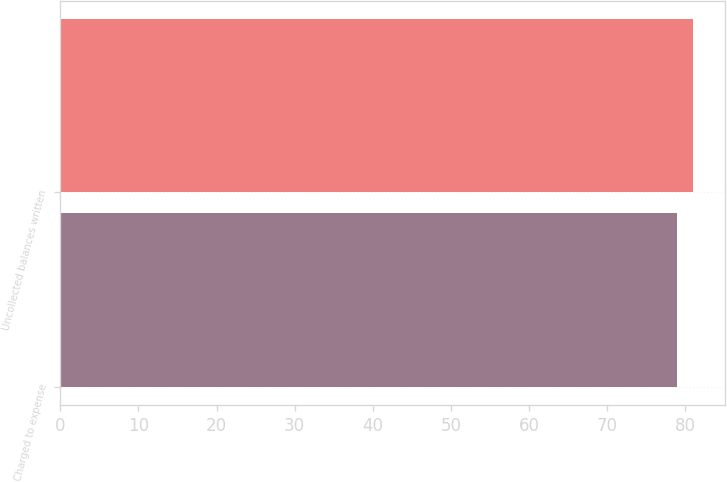Convert chart to OTSL. <chart><loc_0><loc_0><loc_500><loc_500><bar_chart><fcel>Charged to expense<fcel>Uncollected balances written<nl><fcel>79<fcel>81<nl></chart> 